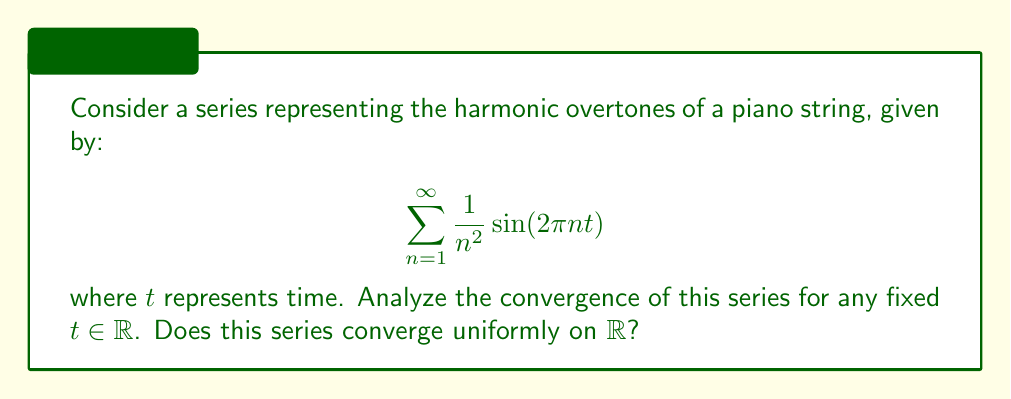What is the answer to this math problem? To analyze the convergence of this series, we'll follow these steps:

1) First, we'll examine pointwise convergence for any fixed $t \in \mathbb{R}$.

2) We know that $|\sin(x)| \leq 1$ for all $x \in \mathbb{R}$. Therefore, for any fixed $t$:

   $$\left|\frac{1}{n^2} \sin(2\pi n t)\right| \leq \frac{1}{n^2}$$

3) Now, we can compare our series to the p-series $\sum_{n=1}^{\infty} \frac{1}{n^2}$. We know this p-series converges because $p = 2 > 1$.

4) By the comparison test, since $\left|\frac{1}{n^2} \sin(2\pi n t)\right| \leq \frac{1}{n^2}$ and $\sum_{n=1}^{\infty} \frac{1}{n^2}$ converges, our series also converges absolutely for any fixed $t$.

5) For uniform convergence, we need to check if the convergence is independent of $t$. Let's consider the sequence of partial sums:

   $$S_N(t) = \sum_{n=1}^{N} \frac{1}{n^2} \sin(2\pi n t)$$

6) For uniform convergence, we need $\sup_{t \in \mathbb{R}} |S_N(t) - S(t)| \to 0$ as $N \to \infty$, where $S(t)$ is the limit function.

7) However, for any $N$, we can always find a $t$ such that $\sin(2\pi n t) = 1$ for all $n \leq N$. In this case:

   $$S_N(t) = \sum_{n=1}^{N} \frac{1}{n^2}$$

8) As $N \to \infty$, this sum approaches $\frac{\pi^2}{6}$, which is not zero.

9) Therefore, $\sup_{t \in \mathbb{R}} |S_N(t) - S(t)|$ does not approach zero as $N \to \infty$, so the series does not converge uniformly on $\mathbb{R}$.
Answer: The series converges pointwise for any fixed $t \in \mathbb{R}$, but it does not converge uniformly on $\mathbb{R}$. 